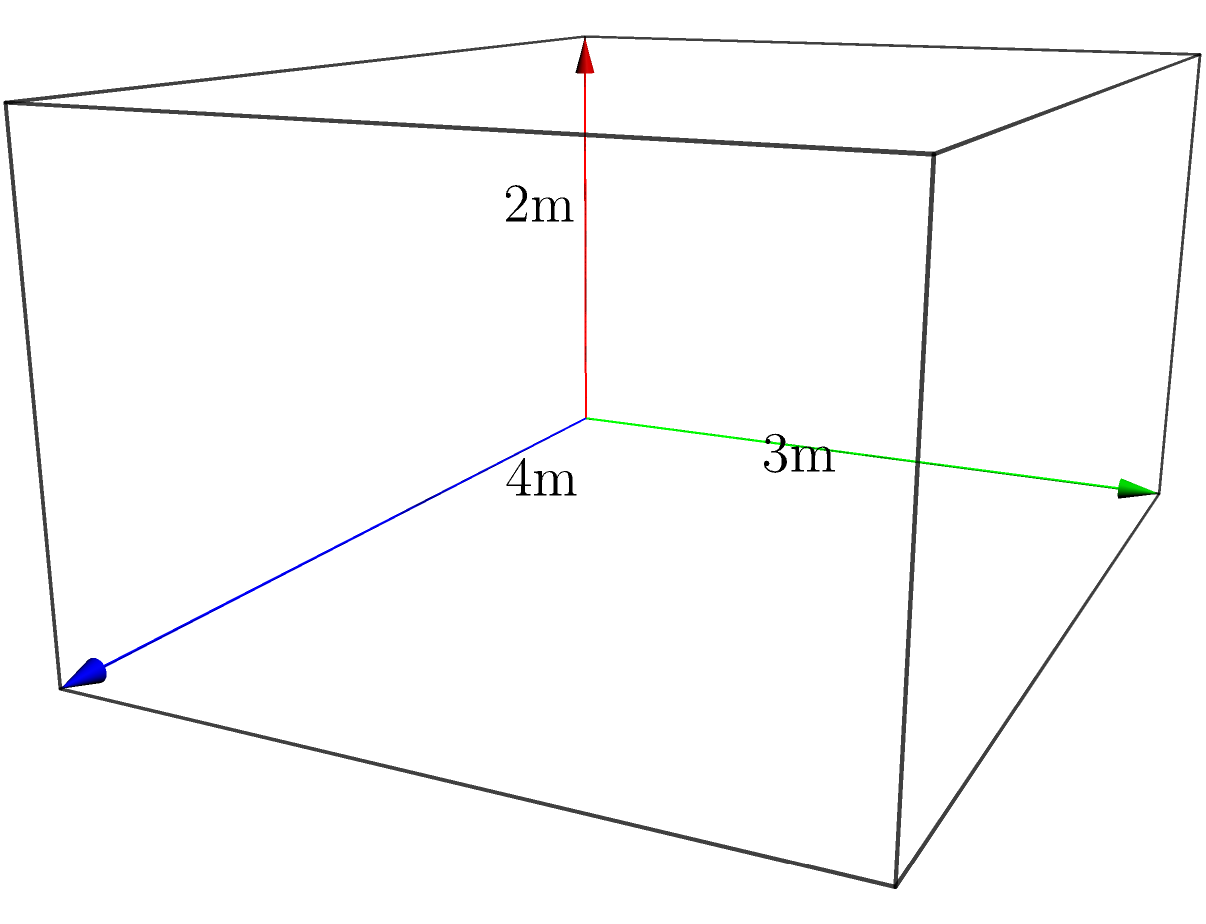As a security expert, you're designing a secure vault for a high-profile client. The vault is represented by a rectangular prism with dimensions 4m x 3m x 2m (length x width x height). What is the volume of this secure vault in cubic meters? To calculate the volume of a rectangular prism, we use the formula:

$$V = l \times w \times h$$

Where:
$V$ = Volume
$l$ = Length
$w$ = Width
$h$ = Height

Given dimensions:
Length $(l) = 4$ m
Width $(w) = 3$ m
Height $(h) = 2$ m

Let's substitute these values into the formula:

$$V = 4 \times 3 \times 2$$

$$V = 24$$

Therefore, the volume of the secure vault is 24 cubic meters.
Answer: 24 m³ 